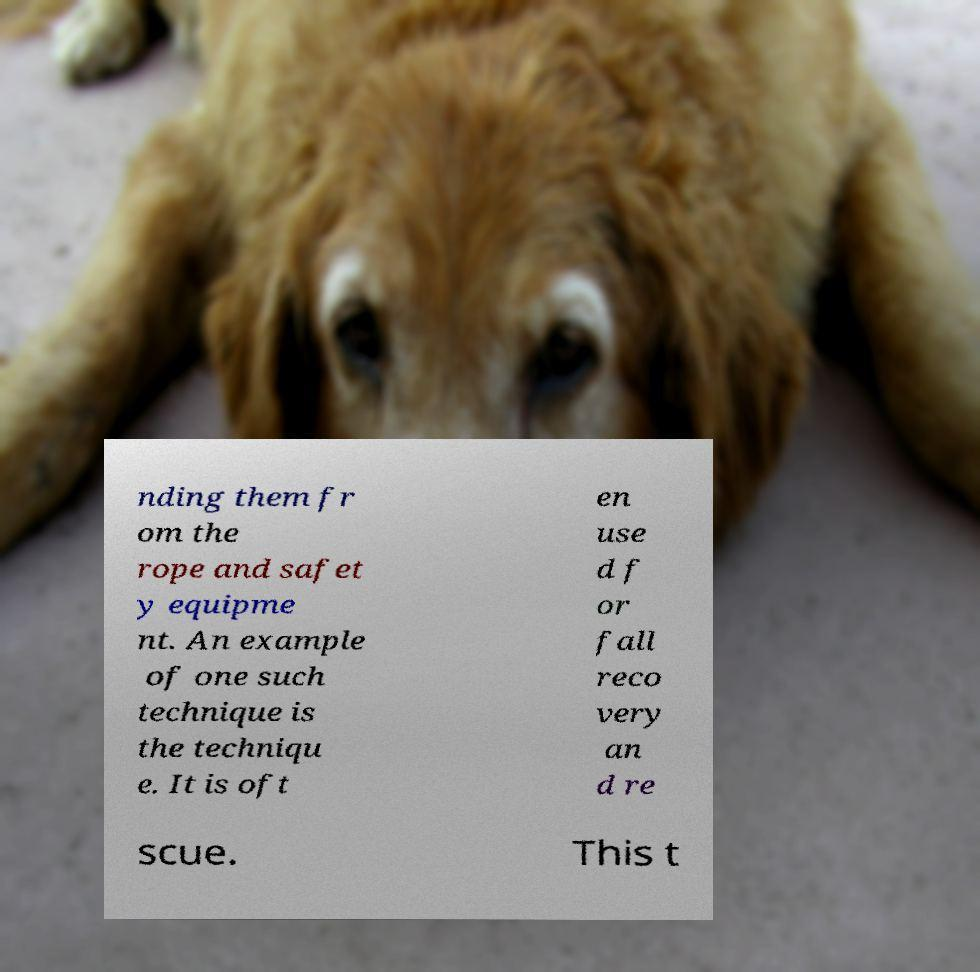Could you assist in decoding the text presented in this image and type it out clearly? nding them fr om the rope and safet y equipme nt. An example of one such technique is the techniqu e. It is oft en use d f or fall reco very an d re scue. This t 